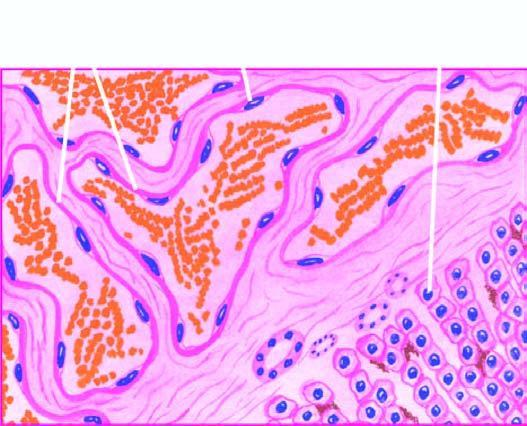how are the vascular spaces?
Answer the question using a single word or phrase. Large 